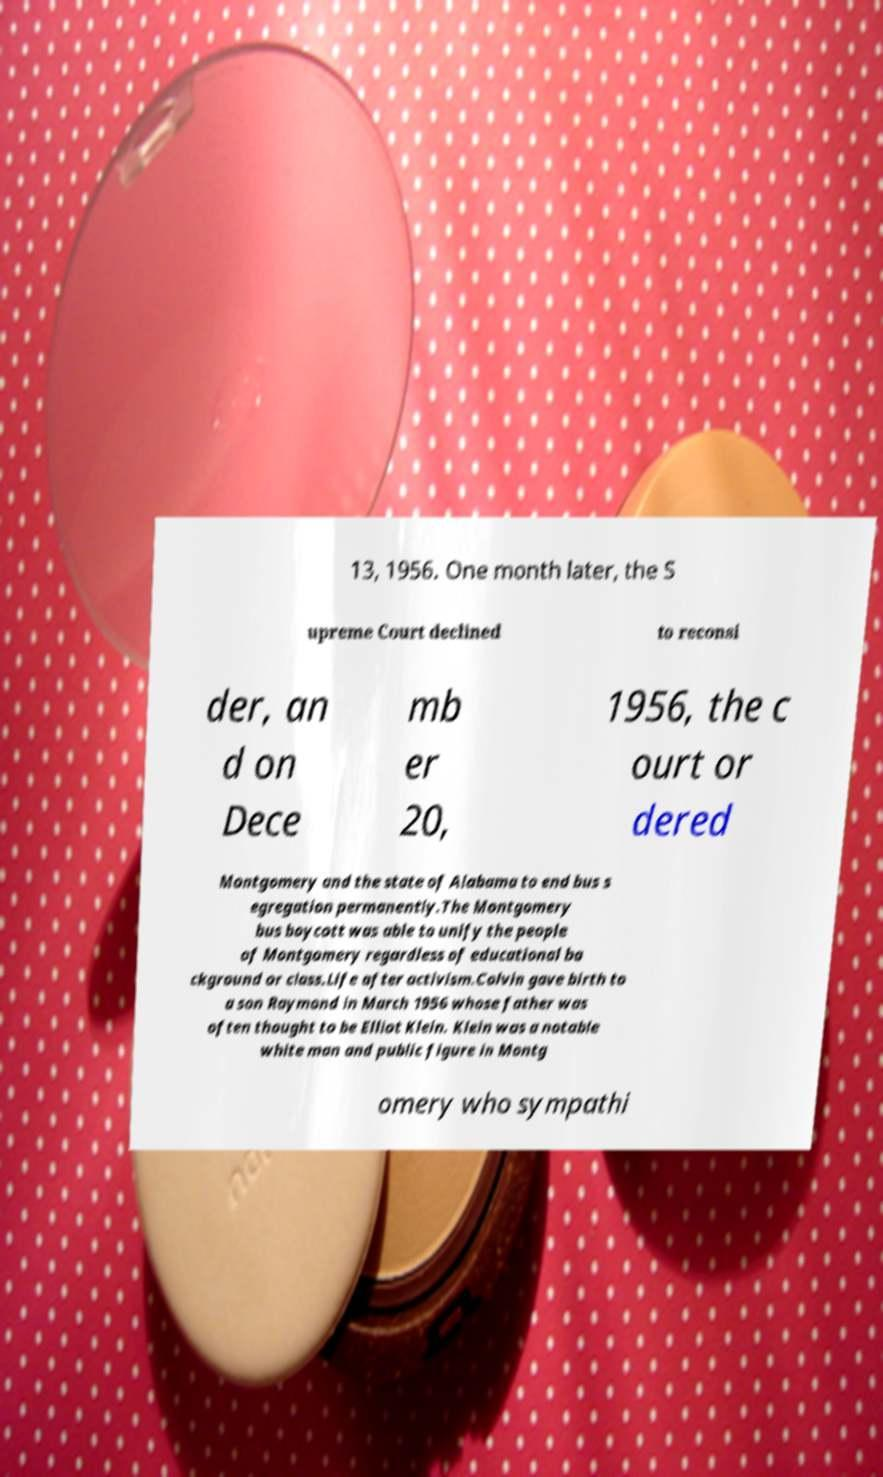I need the written content from this picture converted into text. Can you do that? 13, 1956. One month later, the S upreme Court declined to reconsi der, an d on Dece mb er 20, 1956, the c ourt or dered Montgomery and the state of Alabama to end bus s egregation permanently.The Montgomery bus boycott was able to unify the people of Montgomery regardless of educational ba ckground or class.Life after activism.Colvin gave birth to a son Raymond in March 1956 whose father was often thought to be Elliot Klein. Klein was a notable white man and public figure in Montg omery who sympathi 